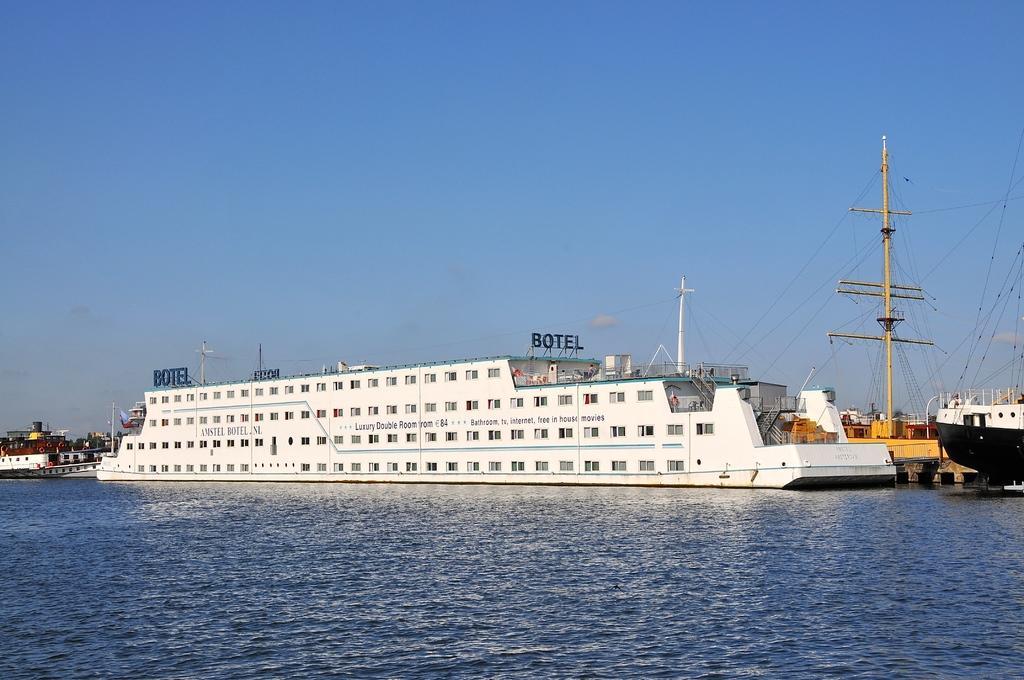Please provide a concise description of this image. In this image I can see few ships in different color. I can see few poles,wires and water. The sky is in blue color. 